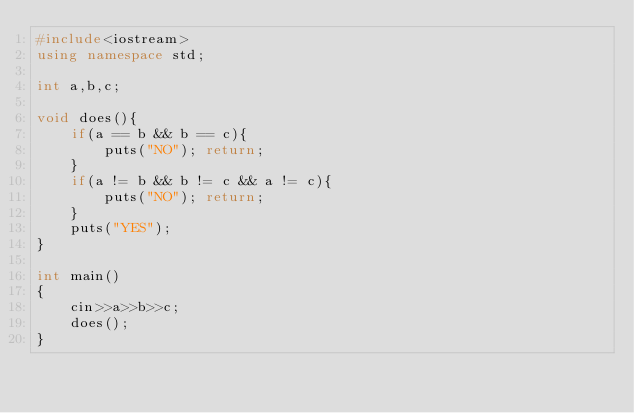<code> <loc_0><loc_0><loc_500><loc_500><_C++_>#include<iostream>
using namespace std;

int a,b,c;

void does(){
    if(a == b && b == c){
        puts("NO"); return;
    }
    if(a != b && b != c && a != c){
        puts("NO"); return;
    }
    puts("YES");
}

int main()
{
    cin>>a>>b>>c;
    does();
}</code> 